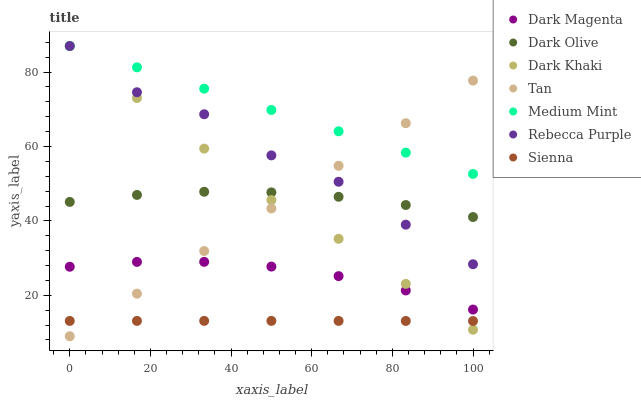Does Sienna have the minimum area under the curve?
Answer yes or no. Yes. Does Medium Mint have the maximum area under the curve?
Answer yes or no. Yes. Does Dark Magenta have the minimum area under the curve?
Answer yes or no. No. Does Dark Magenta have the maximum area under the curve?
Answer yes or no. No. Is Tan the smoothest?
Answer yes or no. Yes. Is Rebecca Purple the roughest?
Answer yes or no. Yes. Is Sienna the smoothest?
Answer yes or no. No. Is Sienna the roughest?
Answer yes or no. No. Does Tan have the lowest value?
Answer yes or no. Yes. Does Sienna have the lowest value?
Answer yes or no. No. Does Rebecca Purple have the highest value?
Answer yes or no. Yes. Does Dark Magenta have the highest value?
Answer yes or no. No. Is Sienna less than Medium Mint?
Answer yes or no. Yes. Is Medium Mint greater than Dark Magenta?
Answer yes or no. Yes. Does Rebecca Purple intersect Dark Olive?
Answer yes or no. Yes. Is Rebecca Purple less than Dark Olive?
Answer yes or no. No. Is Rebecca Purple greater than Dark Olive?
Answer yes or no. No. Does Sienna intersect Medium Mint?
Answer yes or no. No. 